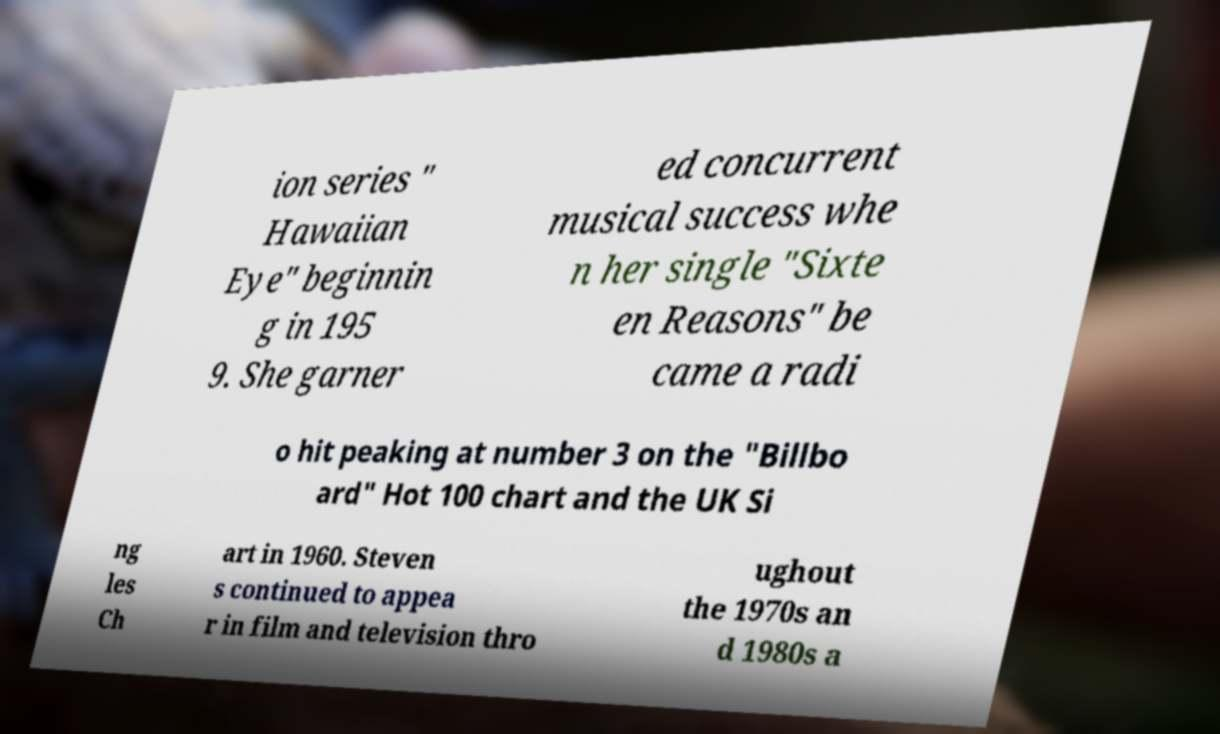Please identify and transcribe the text found in this image. ion series " Hawaiian Eye" beginnin g in 195 9. She garner ed concurrent musical success whe n her single "Sixte en Reasons" be came a radi o hit peaking at number 3 on the "Billbo ard" Hot 100 chart and the UK Si ng les Ch art in 1960. Steven s continued to appea r in film and television thro ughout the 1970s an d 1980s a 